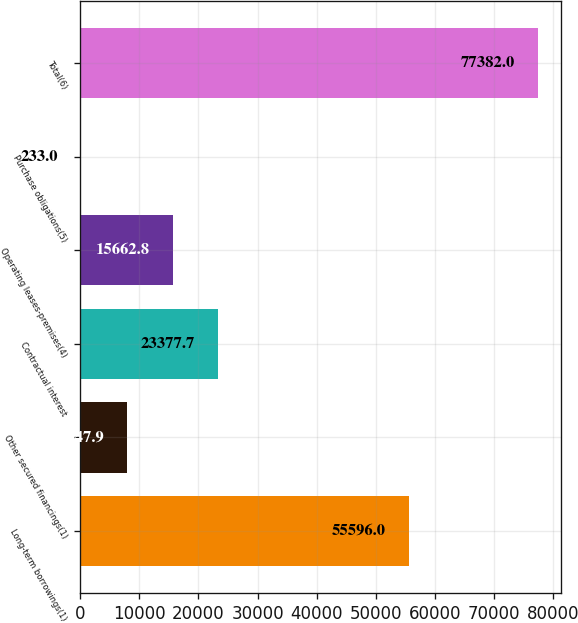Convert chart. <chart><loc_0><loc_0><loc_500><loc_500><bar_chart><fcel>Long-term borrowings(1)<fcel>Other secured financings(1)<fcel>Contractual interest<fcel>Operating leases-premises(4)<fcel>Purchase obligations(5)<fcel>Total(6)<nl><fcel>55596<fcel>7947.9<fcel>23377.7<fcel>15662.8<fcel>233<fcel>77382<nl></chart> 